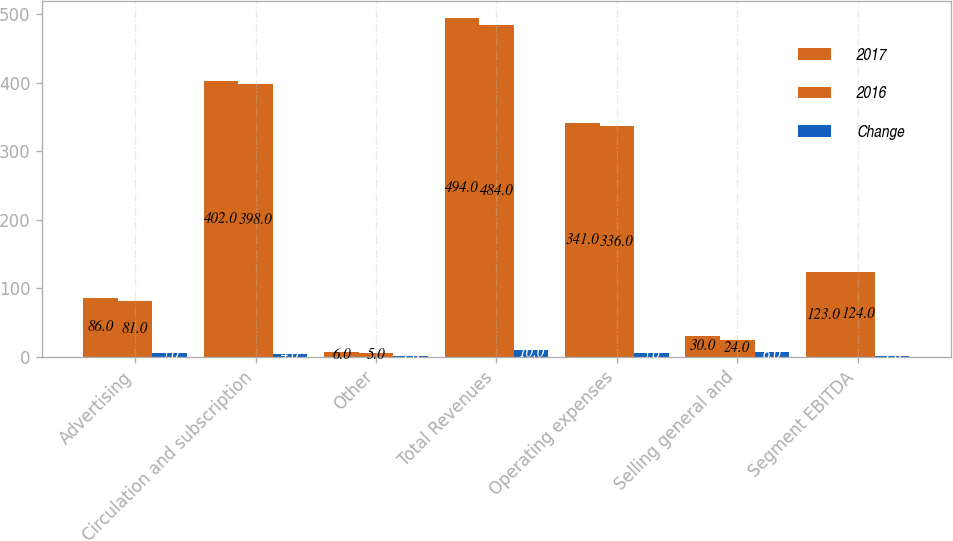<chart> <loc_0><loc_0><loc_500><loc_500><stacked_bar_chart><ecel><fcel>Advertising<fcel>Circulation and subscription<fcel>Other<fcel>Total Revenues<fcel>Operating expenses<fcel>Selling general and<fcel>Segment EBITDA<nl><fcel>2017<fcel>86<fcel>402<fcel>6<fcel>494<fcel>341<fcel>30<fcel>123<nl><fcel>2016<fcel>81<fcel>398<fcel>5<fcel>484<fcel>336<fcel>24<fcel>124<nl><fcel>Change<fcel>5<fcel>4<fcel>1<fcel>10<fcel>5<fcel>6<fcel>1<nl></chart> 